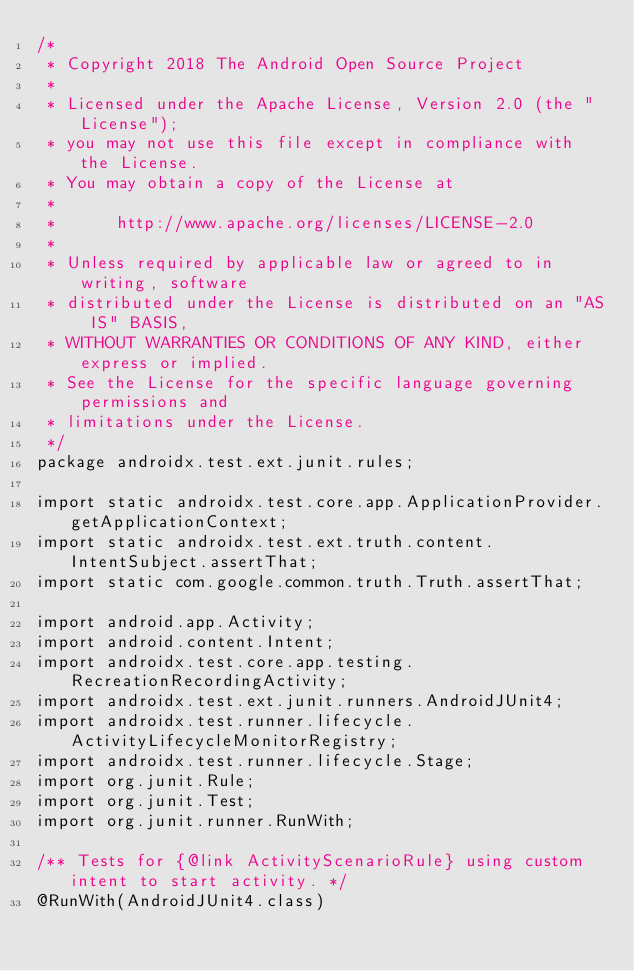<code> <loc_0><loc_0><loc_500><loc_500><_Java_>/*
 * Copyright 2018 The Android Open Source Project
 *
 * Licensed under the Apache License, Version 2.0 (the "License");
 * you may not use this file except in compliance with the License.
 * You may obtain a copy of the License at
 *
 *      http://www.apache.org/licenses/LICENSE-2.0
 *
 * Unless required by applicable law or agreed to in writing, software
 * distributed under the License is distributed on an "AS IS" BASIS,
 * WITHOUT WARRANTIES OR CONDITIONS OF ANY KIND, either express or implied.
 * See the License for the specific language governing permissions and
 * limitations under the License.
 */
package androidx.test.ext.junit.rules;

import static androidx.test.core.app.ApplicationProvider.getApplicationContext;
import static androidx.test.ext.truth.content.IntentSubject.assertThat;
import static com.google.common.truth.Truth.assertThat;

import android.app.Activity;
import android.content.Intent;
import androidx.test.core.app.testing.RecreationRecordingActivity;
import androidx.test.ext.junit.runners.AndroidJUnit4;
import androidx.test.runner.lifecycle.ActivityLifecycleMonitorRegistry;
import androidx.test.runner.lifecycle.Stage;
import org.junit.Rule;
import org.junit.Test;
import org.junit.runner.RunWith;

/** Tests for {@link ActivityScenarioRule} using custom intent to start activity. */
@RunWith(AndroidJUnit4.class)</code> 